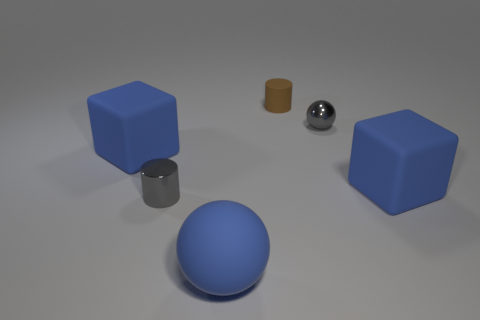Are there any small gray things left of the large matte block that is behind the big blue object right of the small brown object?
Give a very brief answer. No. What is the shape of the small thing that is the same material as the gray cylinder?
Keep it short and to the point. Sphere. Are there more gray metal objects than tiny blue cylinders?
Make the answer very short. Yes. Does the tiny rubber thing have the same shape as the gray thing that is in front of the shiny sphere?
Offer a very short reply. Yes. What is the material of the gray sphere?
Offer a terse response. Metal. What is the color of the small metal object right of the cylinder that is behind the block on the right side of the gray cylinder?
Give a very brief answer. Gray. There is another small object that is the same shape as the tiny matte object; what is it made of?
Your answer should be compact. Metal. How many balls are the same size as the brown cylinder?
Offer a terse response. 1. What number of small matte cylinders are there?
Ensure brevity in your answer.  1. Is the material of the blue ball the same as the small cylinder in front of the brown rubber cylinder?
Your answer should be very brief. No. 